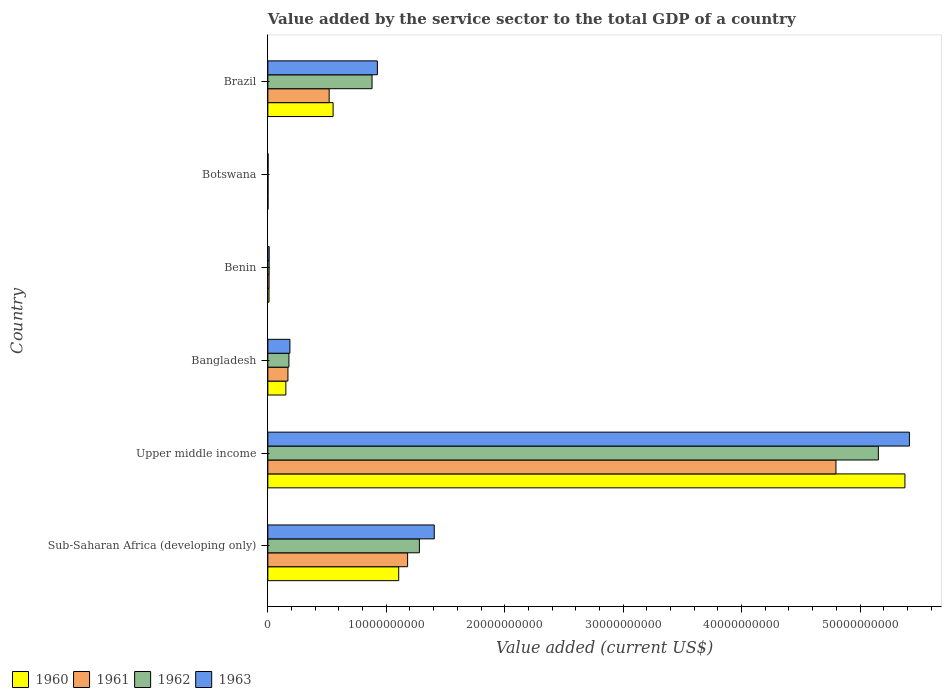How many different coloured bars are there?
Ensure brevity in your answer.  4. How many groups of bars are there?
Your answer should be very brief. 6. How many bars are there on the 1st tick from the bottom?
Provide a short and direct response. 4. What is the label of the 2nd group of bars from the top?
Ensure brevity in your answer.  Botswana. In how many cases, is the number of bars for a given country not equal to the number of legend labels?
Your response must be concise. 0. What is the value added by the service sector to the total GDP in 1963 in Brazil?
Provide a succinct answer. 9.25e+09. Across all countries, what is the maximum value added by the service sector to the total GDP in 1961?
Give a very brief answer. 4.80e+1. Across all countries, what is the minimum value added by the service sector to the total GDP in 1961?
Offer a terse response. 1.51e+07. In which country was the value added by the service sector to the total GDP in 1963 maximum?
Keep it short and to the point. Upper middle income. In which country was the value added by the service sector to the total GDP in 1962 minimum?
Offer a very short reply. Botswana. What is the total value added by the service sector to the total GDP in 1963 in the graph?
Keep it short and to the point. 7.95e+1. What is the difference between the value added by the service sector to the total GDP in 1961 in Bangladesh and that in Benin?
Provide a succinct answer. 1.59e+09. What is the difference between the value added by the service sector to the total GDP in 1960 in Sub-Saharan Africa (developing only) and the value added by the service sector to the total GDP in 1961 in Brazil?
Offer a very short reply. 5.87e+09. What is the average value added by the service sector to the total GDP in 1960 per country?
Ensure brevity in your answer.  1.20e+1. What is the difference between the value added by the service sector to the total GDP in 1961 and value added by the service sector to the total GDP in 1960 in Sub-Saharan Africa (developing only)?
Give a very brief answer. 7.52e+08. What is the ratio of the value added by the service sector to the total GDP in 1960 in Benin to that in Botswana?
Provide a short and direct response. 7.52. Is the value added by the service sector to the total GDP in 1961 in Bangladesh less than that in Sub-Saharan Africa (developing only)?
Make the answer very short. Yes. Is the difference between the value added by the service sector to the total GDP in 1961 in Benin and Botswana greater than the difference between the value added by the service sector to the total GDP in 1960 in Benin and Botswana?
Provide a succinct answer. Yes. What is the difference between the highest and the second highest value added by the service sector to the total GDP in 1961?
Keep it short and to the point. 3.62e+1. What is the difference between the highest and the lowest value added by the service sector to the total GDP in 1962?
Your answer should be compact. 5.15e+1. In how many countries, is the value added by the service sector to the total GDP in 1961 greater than the average value added by the service sector to the total GDP in 1961 taken over all countries?
Your answer should be very brief. 2. What does the 2nd bar from the top in Botswana represents?
Your answer should be very brief. 1962. What does the 2nd bar from the bottom in Bangladesh represents?
Keep it short and to the point. 1961. Are all the bars in the graph horizontal?
Your response must be concise. Yes. What is the difference between two consecutive major ticks on the X-axis?
Offer a terse response. 1.00e+1. Does the graph contain grids?
Keep it short and to the point. No. Where does the legend appear in the graph?
Make the answer very short. Bottom left. What is the title of the graph?
Offer a very short reply. Value added by the service sector to the total GDP of a country. Does "1988" appear as one of the legend labels in the graph?
Give a very brief answer. No. What is the label or title of the X-axis?
Your answer should be very brief. Value added (current US$). What is the label or title of the Y-axis?
Your response must be concise. Country. What is the Value added (current US$) of 1960 in Sub-Saharan Africa (developing only)?
Ensure brevity in your answer.  1.10e+1. What is the Value added (current US$) of 1961 in Sub-Saharan Africa (developing only)?
Your answer should be compact. 1.18e+1. What is the Value added (current US$) of 1962 in Sub-Saharan Africa (developing only)?
Give a very brief answer. 1.28e+1. What is the Value added (current US$) of 1963 in Sub-Saharan Africa (developing only)?
Your response must be concise. 1.41e+1. What is the Value added (current US$) of 1960 in Upper middle income?
Offer a terse response. 5.38e+1. What is the Value added (current US$) in 1961 in Upper middle income?
Offer a very short reply. 4.80e+1. What is the Value added (current US$) in 1962 in Upper middle income?
Give a very brief answer. 5.16e+1. What is the Value added (current US$) in 1963 in Upper middle income?
Ensure brevity in your answer.  5.42e+1. What is the Value added (current US$) of 1960 in Bangladesh?
Keep it short and to the point. 1.52e+09. What is the Value added (current US$) in 1961 in Bangladesh?
Your response must be concise. 1.70e+09. What is the Value added (current US$) in 1962 in Bangladesh?
Give a very brief answer. 1.78e+09. What is the Value added (current US$) in 1963 in Bangladesh?
Keep it short and to the point. 1.86e+09. What is the Value added (current US$) of 1960 in Benin?
Keep it short and to the point. 9.87e+07. What is the Value added (current US$) of 1961 in Benin?
Provide a short and direct response. 1.04e+08. What is the Value added (current US$) in 1962 in Benin?
Ensure brevity in your answer.  1.08e+08. What is the Value added (current US$) of 1963 in Benin?
Your response must be concise. 1.14e+08. What is the Value added (current US$) of 1960 in Botswana?
Offer a terse response. 1.31e+07. What is the Value added (current US$) of 1961 in Botswana?
Your response must be concise. 1.51e+07. What is the Value added (current US$) in 1962 in Botswana?
Ensure brevity in your answer.  1.73e+07. What is the Value added (current US$) of 1963 in Botswana?
Offer a very short reply. 1.93e+07. What is the Value added (current US$) of 1960 in Brazil?
Make the answer very short. 5.51e+09. What is the Value added (current US$) of 1961 in Brazil?
Provide a short and direct response. 5.18e+09. What is the Value added (current US$) in 1962 in Brazil?
Give a very brief answer. 8.80e+09. What is the Value added (current US$) in 1963 in Brazil?
Offer a terse response. 9.25e+09. Across all countries, what is the maximum Value added (current US$) in 1960?
Provide a succinct answer. 5.38e+1. Across all countries, what is the maximum Value added (current US$) in 1961?
Your response must be concise. 4.80e+1. Across all countries, what is the maximum Value added (current US$) of 1962?
Provide a succinct answer. 5.16e+1. Across all countries, what is the maximum Value added (current US$) of 1963?
Provide a short and direct response. 5.42e+1. Across all countries, what is the minimum Value added (current US$) of 1960?
Ensure brevity in your answer.  1.31e+07. Across all countries, what is the minimum Value added (current US$) in 1961?
Make the answer very short. 1.51e+07. Across all countries, what is the minimum Value added (current US$) of 1962?
Your answer should be compact. 1.73e+07. Across all countries, what is the minimum Value added (current US$) in 1963?
Provide a succinct answer. 1.93e+07. What is the total Value added (current US$) in 1960 in the graph?
Provide a short and direct response. 7.20e+1. What is the total Value added (current US$) in 1961 in the graph?
Offer a terse response. 6.68e+1. What is the total Value added (current US$) in 1962 in the graph?
Your answer should be compact. 7.50e+1. What is the total Value added (current US$) in 1963 in the graph?
Your answer should be very brief. 7.95e+1. What is the difference between the Value added (current US$) in 1960 in Sub-Saharan Africa (developing only) and that in Upper middle income?
Make the answer very short. -4.27e+1. What is the difference between the Value added (current US$) of 1961 in Sub-Saharan Africa (developing only) and that in Upper middle income?
Ensure brevity in your answer.  -3.62e+1. What is the difference between the Value added (current US$) of 1962 in Sub-Saharan Africa (developing only) and that in Upper middle income?
Make the answer very short. -3.88e+1. What is the difference between the Value added (current US$) of 1963 in Sub-Saharan Africa (developing only) and that in Upper middle income?
Ensure brevity in your answer.  -4.01e+1. What is the difference between the Value added (current US$) of 1960 in Sub-Saharan Africa (developing only) and that in Bangladesh?
Offer a terse response. 9.53e+09. What is the difference between the Value added (current US$) of 1961 in Sub-Saharan Africa (developing only) and that in Bangladesh?
Provide a succinct answer. 1.01e+1. What is the difference between the Value added (current US$) in 1962 in Sub-Saharan Africa (developing only) and that in Bangladesh?
Give a very brief answer. 1.10e+1. What is the difference between the Value added (current US$) of 1963 in Sub-Saharan Africa (developing only) and that in Bangladesh?
Provide a short and direct response. 1.22e+1. What is the difference between the Value added (current US$) of 1960 in Sub-Saharan Africa (developing only) and that in Benin?
Make the answer very short. 1.10e+1. What is the difference between the Value added (current US$) of 1961 in Sub-Saharan Africa (developing only) and that in Benin?
Your response must be concise. 1.17e+1. What is the difference between the Value added (current US$) of 1962 in Sub-Saharan Africa (developing only) and that in Benin?
Give a very brief answer. 1.27e+1. What is the difference between the Value added (current US$) in 1963 in Sub-Saharan Africa (developing only) and that in Benin?
Make the answer very short. 1.39e+1. What is the difference between the Value added (current US$) of 1960 in Sub-Saharan Africa (developing only) and that in Botswana?
Provide a short and direct response. 1.10e+1. What is the difference between the Value added (current US$) in 1961 in Sub-Saharan Africa (developing only) and that in Botswana?
Offer a very short reply. 1.18e+1. What is the difference between the Value added (current US$) in 1962 in Sub-Saharan Africa (developing only) and that in Botswana?
Keep it short and to the point. 1.28e+1. What is the difference between the Value added (current US$) in 1963 in Sub-Saharan Africa (developing only) and that in Botswana?
Your answer should be very brief. 1.40e+1. What is the difference between the Value added (current US$) in 1960 in Sub-Saharan Africa (developing only) and that in Brazil?
Give a very brief answer. 5.54e+09. What is the difference between the Value added (current US$) in 1961 in Sub-Saharan Africa (developing only) and that in Brazil?
Make the answer very short. 6.62e+09. What is the difference between the Value added (current US$) of 1962 in Sub-Saharan Africa (developing only) and that in Brazil?
Ensure brevity in your answer.  4.00e+09. What is the difference between the Value added (current US$) in 1963 in Sub-Saharan Africa (developing only) and that in Brazil?
Keep it short and to the point. 4.80e+09. What is the difference between the Value added (current US$) in 1960 in Upper middle income and that in Bangladesh?
Your response must be concise. 5.23e+1. What is the difference between the Value added (current US$) of 1961 in Upper middle income and that in Bangladesh?
Provide a succinct answer. 4.63e+1. What is the difference between the Value added (current US$) of 1962 in Upper middle income and that in Bangladesh?
Your answer should be very brief. 4.98e+1. What is the difference between the Value added (current US$) in 1963 in Upper middle income and that in Bangladesh?
Offer a terse response. 5.23e+1. What is the difference between the Value added (current US$) in 1960 in Upper middle income and that in Benin?
Your answer should be compact. 5.37e+1. What is the difference between the Value added (current US$) of 1961 in Upper middle income and that in Benin?
Offer a terse response. 4.79e+1. What is the difference between the Value added (current US$) of 1962 in Upper middle income and that in Benin?
Ensure brevity in your answer.  5.14e+1. What is the difference between the Value added (current US$) in 1963 in Upper middle income and that in Benin?
Your answer should be compact. 5.41e+1. What is the difference between the Value added (current US$) of 1960 in Upper middle income and that in Botswana?
Make the answer very short. 5.38e+1. What is the difference between the Value added (current US$) of 1961 in Upper middle income and that in Botswana?
Make the answer very short. 4.80e+1. What is the difference between the Value added (current US$) in 1962 in Upper middle income and that in Botswana?
Keep it short and to the point. 5.15e+1. What is the difference between the Value added (current US$) of 1963 in Upper middle income and that in Botswana?
Offer a terse response. 5.42e+1. What is the difference between the Value added (current US$) in 1960 in Upper middle income and that in Brazil?
Offer a terse response. 4.83e+1. What is the difference between the Value added (current US$) in 1961 in Upper middle income and that in Brazil?
Keep it short and to the point. 4.28e+1. What is the difference between the Value added (current US$) in 1962 in Upper middle income and that in Brazil?
Give a very brief answer. 4.28e+1. What is the difference between the Value added (current US$) in 1963 in Upper middle income and that in Brazil?
Provide a short and direct response. 4.49e+1. What is the difference between the Value added (current US$) of 1960 in Bangladesh and that in Benin?
Provide a succinct answer. 1.42e+09. What is the difference between the Value added (current US$) of 1961 in Bangladesh and that in Benin?
Make the answer very short. 1.59e+09. What is the difference between the Value added (current US$) of 1962 in Bangladesh and that in Benin?
Give a very brief answer. 1.67e+09. What is the difference between the Value added (current US$) of 1963 in Bangladesh and that in Benin?
Keep it short and to the point. 1.75e+09. What is the difference between the Value added (current US$) in 1960 in Bangladesh and that in Botswana?
Offer a terse response. 1.51e+09. What is the difference between the Value added (current US$) of 1961 in Bangladesh and that in Botswana?
Your answer should be compact. 1.68e+09. What is the difference between the Value added (current US$) of 1962 in Bangladesh and that in Botswana?
Keep it short and to the point. 1.76e+09. What is the difference between the Value added (current US$) of 1963 in Bangladesh and that in Botswana?
Offer a terse response. 1.85e+09. What is the difference between the Value added (current US$) in 1960 in Bangladesh and that in Brazil?
Your answer should be compact. -3.99e+09. What is the difference between the Value added (current US$) of 1961 in Bangladesh and that in Brazil?
Ensure brevity in your answer.  -3.48e+09. What is the difference between the Value added (current US$) in 1962 in Bangladesh and that in Brazil?
Provide a succinct answer. -7.02e+09. What is the difference between the Value added (current US$) in 1963 in Bangladesh and that in Brazil?
Keep it short and to the point. -7.38e+09. What is the difference between the Value added (current US$) in 1960 in Benin and that in Botswana?
Your answer should be compact. 8.55e+07. What is the difference between the Value added (current US$) of 1961 in Benin and that in Botswana?
Offer a very short reply. 8.86e+07. What is the difference between the Value added (current US$) of 1962 in Benin and that in Botswana?
Offer a very short reply. 9.03e+07. What is the difference between the Value added (current US$) of 1963 in Benin and that in Botswana?
Provide a short and direct response. 9.45e+07. What is the difference between the Value added (current US$) in 1960 in Benin and that in Brazil?
Offer a very short reply. -5.41e+09. What is the difference between the Value added (current US$) of 1961 in Benin and that in Brazil?
Give a very brief answer. -5.07e+09. What is the difference between the Value added (current US$) of 1962 in Benin and that in Brazil?
Ensure brevity in your answer.  -8.69e+09. What is the difference between the Value added (current US$) of 1963 in Benin and that in Brazil?
Provide a succinct answer. -9.13e+09. What is the difference between the Value added (current US$) of 1960 in Botswana and that in Brazil?
Give a very brief answer. -5.50e+09. What is the difference between the Value added (current US$) of 1961 in Botswana and that in Brazil?
Your response must be concise. -5.16e+09. What is the difference between the Value added (current US$) in 1962 in Botswana and that in Brazil?
Offer a very short reply. -8.78e+09. What is the difference between the Value added (current US$) of 1963 in Botswana and that in Brazil?
Give a very brief answer. -9.23e+09. What is the difference between the Value added (current US$) in 1960 in Sub-Saharan Africa (developing only) and the Value added (current US$) in 1961 in Upper middle income?
Offer a terse response. -3.69e+1. What is the difference between the Value added (current US$) of 1960 in Sub-Saharan Africa (developing only) and the Value added (current US$) of 1962 in Upper middle income?
Your answer should be very brief. -4.05e+1. What is the difference between the Value added (current US$) of 1960 in Sub-Saharan Africa (developing only) and the Value added (current US$) of 1963 in Upper middle income?
Your answer should be compact. -4.31e+1. What is the difference between the Value added (current US$) of 1961 in Sub-Saharan Africa (developing only) and the Value added (current US$) of 1962 in Upper middle income?
Provide a short and direct response. -3.97e+1. What is the difference between the Value added (current US$) in 1961 in Sub-Saharan Africa (developing only) and the Value added (current US$) in 1963 in Upper middle income?
Your answer should be compact. -4.24e+1. What is the difference between the Value added (current US$) in 1962 in Sub-Saharan Africa (developing only) and the Value added (current US$) in 1963 in Upper middle income?
Offer a very short reply. -4.14e+1. What is the difference between the Value added (current US$) of 1960 in Sub-Saharan Africa (developing only) and the Value added (current US$) of 1961 in Bangladesh?
Provide a succinct answer. 9.35e+09. What is the difference between the Value added (current US$) of 1960 in Sub-Saharan Africa (developing only) and the Value added (current US$) of 1962 in Bangladesh?
Offer a very short reply. 9.27e+09. What is the difference between the Value added (current US$) in 1960 in Sub-Saharan Africa (developing only) and the Value added (current US$) in 1963 in Bangladesh?
Keep it short and to the point. 9.19e+09. What is the difference between the Value added (current US$) of 1961 in Sub-Saharan Africa (developing only) and the Value added (current US$) of 1962 in Bangladesh?
Provide a succinct answer. 1.00e+1. What is the difference between the Value added (current US$) of 1961 in Sub-Saharan Africa (developing only) and the Value added (current US$) of 1963 in Bangladesh?
Make the answer very short. 9.94e+09. What is the difference between the Value added (current US$) in 1962 in Sub-Saharan Africa (developing only) and the Value added (current US$) in 1963 in Bangladesh?
Keep it short and to the point. 1.09e+1. What is the difference between the Value added (current US$) of 1960 in Sub-Saharan Africa (developing only) and the Value added (current US$) of 1961 in Benin?
Your response must be concise. 1.09e+1. What is the difference between the Value added (current US$) of 1960 in Sub-Saharan Africa (developing only) and the Value added (current US$) of 1962 in Benin?
Offer a very short reply. 1.09e+1. What is the difference between the Value added (current US$) of 1960 in Sub-Saharan Africa (developing only) and the Value added (current US$) of 1963 in Benin?
Keep it short and to the point. 1.09e+1. What is the difference between the Value added (current US$) in 1961 in Sub-Saharan Africa (developing only) and the Value added (current US$) in 1962 in Benin?
Provide a succinct answer. 1.17e+1. What is the difference between the Value added (current US$) in 1961 in Sub-Saharan Africa (developing only) and the Value added (current US$) in 1963 in Benin?
Ensure brevity in your answer.  1.17e+1. What is the difference between the Value added (current US$) in 1962 in Sub-Saharan Africa (developing only) and the Value added (current US$) in 1963 in Benin?
Keep it short and to the point. 1.27e+1. What is the difference between the Value added (current US$) in 1960 in Sub-Saharan Africa (developing only) and the Value added (current US$) in 1961 in Botswana?
Offer a terse response. 1.10e+1. What is the difference between the Value added (current US$) in 1960 in Sub-Saharan Africa (developing only) and the Value added (current US$) in 1962 in Botswana?
Make the answer very short. 1.10e+1. What is the difference between the Value added (current US$) of 1960 in Sub-Saharan Africa (developing only) and the Value added (current US$) of 1963 in Botswana?
Give a very brief answer. 1.10e+1. What is the difference between the Value added (current US$) in 1961 in Sub-Saharan Africa (developing only) and the Value added (current US$) in 1962 in Botswana?
Provide a succinct answer. 1.18e+1. What is the difference between the Value added (current US$) of 1961 in Sub-Saharan Africa (developing only) and the Value added (current US$) of 1963 in Botswana?
Give a very brief answer. 1.18e+1. What is the difference between the Value added (current US$) of 1962 in Sub-Saharan Africa (developing only) and the Value added (current US$) of 1963 in Botswana?
Make the answer very short. 1.28e+1. What is the difference between the Value added (current US$) of 1960 in Sub-Saharan Africa (developing only) and the Value added (current US$) of 1961 in Brazil?
Your response must be concise. 5.87e+09. What is the difference between the Value added (current US$) in 1960 in Sub-Saharan Africa (developing only) and the Value added (current US$) in 1962 in Brazil?
Your response must be concise. 2.25e+09. What is the difference between the Value added (current US$) of 1960 in Sub-Saharan Africa (developing only) and the Value added (current US$) of 1963 in Brazil?
Ensure brevity in your answer.  1.80e+09. What is the difference between the Value added (current US$) of 1961 in Sub-Saharan Africa (developing only) and the Value added (current US$) of 1962 in Brazil?
Offer a very short reply. 3.00e+09. What is the difference between the Value added (current US$) of 1961 in Sub-Saharan Africa (developing only) and the Value added (current US$) of 1963 in Brazil?
Your answer should be very brief. 2.55e+09. What is the difference between the Value added (current US$) of 1962 in Sub-Saharan Africa (developing only) and the Value added (current US$) of 1963 in Brazil?
Your answer should be very brief. 3.55e+09. What is the difference between the Value added (current US$) of 1960 in Upper middle income and the Value added (current US$) of 1961 in Bangladesh?
Make the answer very short. 5.21e+1. What is the difference between the Value added (current US$) in 1960 in Upper middle income and the Value added (current US$) in 1962 in Bangladesh?
Provide a succinct answer. 5.20e+1. What is the difference between the Value added (current US$) in 1960 in Upper middle income and the Value added (current US$) in 1963 in Bangladesh?
Your answer should be very brief. 5.19e+1. What is the difference between the Value added (current US$) of 1961 in Upper middle income and the Value added (current US$) of 1962 in Bangladesh?
Keep it short and to the point. 4.62e+1. What is the difference between the Value added (current US$) in 1961 in Upper middle income and the Value added (current US$) in 1963 in Bangladesh?
Give a very brief answer. 4.61e+1. What is the difference between the Value added (current US$) of 1962 in Upper middle income and the Value added (current US$) of 1963 in Bangladesh?
Your answer should be compact. 4.97e+1. What is the difference between the Value added (current US$) of 1960 in Upper middle income and the Value added (current US$) of 1961 in Benin?
Make the answer very short. 5.37e+1. What is the difference between the Value added (current US$) in 1960 in Upper middle income and the Value added (current US$) in 1962 in Benin?
Provide a succinct answer. 5.37e+1. What is the difference between the Value added (current US$) in 1960 in Upper middle income and the Value added (current US$) in 1963 in Benin?
Offer a terse response. 5.37e+1. What is the difference between the Value added (current US$) in 1961 in Upper middle income and the Value added (current US$) in 1962 in Benin?
Keep it short and to the point. 4.79e+1. What is the difference between the Value added (current US$) in 1961 in Upper middle income and the Value added (current US$) in 1963 in Benin?
Your answer should be very brief. 4.79e+1. What is the difference between the Value added (current US$) of 1962 in Upper middle income and the Value added (current US$) of 1963 in Benin?
Give a very brief answer. 5.14e+1. What is the difference between the Value added (current US$) of 1960 in Upper middle income and the Value added (current US$) of 1961 in Botswana?
Make the answer very short. 5.38e+1. What is the difference between the Value added (current US$) of 1960 in Upper middle income and the Value added (current US$) of 1962 in Botswana?
Offer a terse response. 5.38e+1. What is the difference between the Value added (current US$) in 1960 in Upper middle income and the Value added (current US$) in 1963 in Botswana?
Offer a terse response. 5.38e+1. What is the difference between the Value added (current US$) of 1961 in Upper middle income and the Value added (current US$) of 1962 in Botswana?
Keep it short and to the point. 4.80e+1. What is the difference between the Value added (current US$) in 1961 in Upper middle income and the Value added (current US$) in 1963 in Botswana?
Offer a terse response. 4.80e+1. What is the difference between the Value added (current US$) of 1962 in Upper middle income and the Value added (current US$) of 1963 in Botswana?
Provide a succinct answer. 5.15e+1. What is the difference between the Value added (current US$) of 1960 in Upper middle income and the Value added (current US$) of 1961 in Brazil?
Ensure brevity in your answer.  4.86e+1. What is the difference between the Value added (current US$) in 1960 in Upper middle income and the Value added (current US$) in 1962 in Brazil?
Your response must be concise. 4.50e+1. What is the difference between the Value added (current US$) in 1960 in Upper middle income and the Value added (current US$) in 1963 in Brazil?
Provide a short and direct response. 4.45e+1. What is the difference between the Value added (current US$) in 1961 in Upper middle income and the Value added (current US$) in 1962 in Brazil?
Your answer should be compact. 3.92e+1. What is the difference between the Value added (current US$) of 1961 in Upper middle income and the Value added (current US$) of 1963 in Brazil?
Keep it short and to the point. 3.87e+1. What is the difference between the Value added (current US$) in 1962 in Upper middle income and the Value added (current US$) in 1963 in Brazil?
Offer a terse response. 4.23e+1. What is the difference between the Value added (current US$) of 1960 in Bangladesh and the Value added (current US$) of 1961 in Benin?
Provide a succinct answer. 1.42e+09. What is the difference between the Value added (current US$) in 1960 in Bangladesh and the Value added (current US$) in 1962 in Benin?
Offer a very short reply. 1.41e+09. What is the difference between the Value added (current US$) of 1960 in Bangladesh and the Value added (current US$) of 1963 in Benin?
Offer a very short reply. 1.41e+09. What is the difference between the Value added (current US$) in 1961 in Bangladesh and the Value added (current US$) in 1962 in Benin?
Offer a very short reply. 1.59e+09. What is the difference between the Value added (current US$) of 1961 in Bangladesh and the Value added (current US$) of 1963 in Benin?
Make the answer very short. 1.58e+09. What is the difference between the Value added (current US$) in 1962 in Bangladesh and the Value added (current US$) in 1963 in Benin?
Give a very brief answer. 1.67e+09. What is the difference between the Value added (current US$) in 1960 in Bangladesh and the Value added (current US$) in 1961 in Botswana?
Give a very brief answer. 1.50e+09. What is the difference between the Value added (current US$) in 1960 in Bangladesh and the Value added (current US$) in 1962 in Botswana?
Provide a succinct answer. 1.50e+09. What is the difference between the Value added (current US$) in 1960 in Bangladesh and the Value added (current US$) in 1963 in Botswana?
Keep it short and to the point. 1.50e+09. What is the difference between the Value added (current US$) in 1961 in Bangladesh and the Value added (current US$) in 1962 in Botswana?
Your answer should be compact. 1.68e+09. What is the difference between the Value added (current US$) of 1961 in Bangladesh and the Value added (current US$) of 1963 in Botswana?
Your answer should be very brief. 1.68e+09. What is the difference between the Value added (current US$) in 1962 in Bangladesh and the Value added (current US$) in 1963 in Botswana?
Your response must be concise. 1.76e+09. What is the difference between the Value added (current US$) of 1960 in Bangladesh and the Value added (current US$) of 1961 in Brazil?
Your answer should be very brief. -3.66e+09. What is the difference between the Value added (current US$) in 1960 in Bangladesh and the Value added (current US$) in 1962 in Brazil?
Keep it short and to the point. -7.28e+09. What is the difference between the Value added (current US$) of 1960 in Bangladesh and the Value added (current US$) of 1963 in Brazil?
Make the answer very short. -7.73e+09. What is the difference between the Value added (current US$) in 1961 in Bangladesh and the Value added (current US$) in 1962 in Brazil?
Provide a short and direct response. -7.10e+09. What is the difference between the Value added (current US$) in 1961 in Bangladesh and the Value added (current US$) in 1963 in Brazil?
Offer a very short reply. -7.55e+09. What is the difference between the Value added (current US$) of 1962 in Bangladesh and the Value added (current US$) of 1963 in Brazil?
Provide a short and direct response. -7.47e+09. What is the difference between the Value added (current US$) of 1960 in Benin and the Value added (current US$) of 1961 in Botswana?
Ensure brevity in your answer.  8.36e+07. What is the difference between the Value added (current US$) in 1960 in Benin and the Value added (current US$) in 1962 in Botswana?
Give a very brief answer. 8.14e+07. What is the difference between the Value added (current US$) in 1960 in Benin and the Value added (current US$) in 1963 in Botswana?
Make the answer very short. 7.94e+07. What is the difference between the Value added (current US$) of 1961 in Benin and the Value added (current US$) of 1962 in Botswana?
Keep it short and to the point. 8.64e+07. What is the difference between the Value added (current US$) in 1961 in Benin and the Value added (current US$) in 1963 in Botswana?
Make the answer very short. 8.44e+07. What is the difference between the Value added (current US$) of 1962 in Benin and the Value added (current US$) of 1963 in Botswana?
Ensure brevity in your answer.  8.83e+07. What is the difference between the Value added (current US$) of 1960 in Benin and the Value added (current US$) of 1961 in Brazil?
Your answer should be compact. -5.08e+09. What is the difference between the Value added (current US$) of 1960 in Benin and the Value added (current US$) of 1962 in Brazil?
Your response must be concise. -8.70e+09. What is the difference between the Value added (current US$) in 1960 in Benin and the Value added (current US$) in 1963 in Brazil?
Offer a terse response. -9.15e+09. What is the difference between the Value added (current US$) of 1961 in Benin and the Value added (current US$) of 1962 in Brazil?
Your answer should be compact. -8.70e+09. What is the difference between the Value added (current US$) in 1961 in Benin and the Value added (current US$) in 1963 in Brazil?
Your response must be concise. -9.14e+09. What is the difference between the Value added (current US$) of 1962 in Benin and the Value added (current US$) of 1963 in Brazil?
Your answer should be very brief. -9.14e+09. What is the difference between the Value added (current US$) of 1960 in Botswana and the Value added (current US$) of 1961 in Brazil?
Your answer should be very brief. -5.17e+09. What is the difference between the Value added (current US$) in 1960 in Botswana and the Value added (current US$) in 1962 in Brazil?
Provide a succinct answer. -8.79e+09. What is the difference between the Value added (current US$) of 1960 in Botswana and the Value added (current US$) of 1963 in Brazil?
Your answer should be very brief. -9.24e+09. What is the difference between the Value added (current US$) of 1961 in Botswana and the Value added (current US$) of 1962 in Brazil?
Your answer should be compact. -8.78e+09. What is the difference between the Value added (current US$) in 1961 in Botswana and the Value added (current US$) in 1963 in Brazil?
Ensure brevity in your answer.  -9.23e+09. What is the difference between the Value added (current US$) in 1962 in Botswana and the Value added (current US$) in 1963 in Brazil?
Give a very brief answer. -9.23e+09. What is the average Value added (current US$) in 1960 per country?
Make the answer very short. 1.20e+1. What is the average Value added (current US$) in 1961 per country?
Provide a succinct answer. 1.11e+1. What is the average Value added (current US$) of 1962 per country?
Provide a succinct answer. 1.25e+1. What is the average Value added (current US$) of 1963 per country?
Your response must be concise. 1.32e+1. What is the difference between the Value added (current US$) in 1960 and Value added (current US$) in 1961 in Sub-Saharan Africa (developing only)?
Your response must be concise. -7.52e+08. What is the difference between the Value added (current US$) in 1960 and Value added (current US$) in 1962 in Sub-Saharan Africa (developing only)?
Offer a terse response. -1.75e+09. What is the difference between the Value added (current US$) in 1960 and Value added (current US$) in 1963 in Sub-Saharan Africa (developing only)?
Keep it short and to the point. -3.00e+09. What is the difference between the Value added (current US$) in 1961 and Value added (current US$) in 1962 in Sub-Saharan Africa (developing only)?
Keep it short and to the point. -9.93e+08. What is the difference between the Value added (current US$) of 1961 and Value added (current US$) of 1963 in Sub-Saharan Africa (developing only)?
Your answer should be very brief. -2.25e+09. What is the difference between the Value added (current US$) of 1962 and Value added (current US$) of 1963 in Sub-Saharan Africa (developing only)?
Offer a terse response. -1.26e+09. What is the difference between the Value added (current US$) of 1960 and Value added (current US$) of 1961 in Upper middle income?
Provide a short and direct response. 5.82e+09. What is the difference between the Value added (current US$) of 1960 and Value added (current US$) of 1962 in Upper middle income?
Give a very brief answer. 2.24e+09. What is the difference between the Value added (current US$) of 1960 and Value added (current US$) of 1963 in Upper middle income?
Give a very brief answer. -3.78e+08. What is the difference between the Value added (current US$) in 1961 and Value added (current US$) in 1962 in Upper middle income?
Make the answer very short. -3.58e+09. What is the difference between the Value added (current US$) of 1961 and Value added (current US$) of 1963 in Upper middle income?
Give a very brief answer. -6.20e+09. What is the difference between the Value added (current US$) in 1962 and Value added (current US$) in 1963 in Upper middle income?
Your answer should be compact. -2.62e+09. What is the difference between the Value added (current US$) of 1960 and Value added (current US$) of 1961 in Bangladesh?
Ensure brevity in your answer.  -1.77e+08. What is the difference between the Value added (current US$) in 1960 and Value added (current US$) in 1962 in Bangladesh?
Give a very brief answer. -2.60e+08. What is the difference between the Value added (current US$) of 1960 and Value added (current US$) of 1963 in Bangladesh?
Offer a terse response. -3.45e+08. What is the difference between the Value added (current US$) in 1961 and Value added (current US$) in 1962 in Bangladesh?
Your answer should be very brief. -8.27e+07. What is the difference between the Value added (current US$) of 1961 and Value added (current US$) of 1963 in Bangladesh?
Give a very brief answer. -1.68e+08. What is the difference between the Value added (current US$) in 1962 and Value added (current US$) in 1963 in Bangladesh?
Provide a short and direct response. -8.50e+07. What is the difference between the Value added (current US$) of 1960 and Value added (current US$) of 1961 in Benin?
Keep it short and to the point. -5.02e+06. What is the difference between the Value added (current US$) in 1960 and Value added (current US$) in 1962 in Benin?
Your answer should be compact. -8.92e+06. What is the difference between the Value added (current US$) of 1960 and Value added (current US$) of 1963 in Benin?
Provide a short and direct response. -1.51e+07. What is the difference between the Value added (current US$) in 1961 and Value added (current US$) in 1962 in Benin?
Give a very brief answer. -3.90e+06. What is the difference between the Value added (current US$) of 1961 and Value added (current US$) of 1963 in Benin?
Keep it short and to the point. -1.01e+07. What is the difference between the Value added (current US$) in 1962 and Value added (current US$) in 1963 in Benin?
Offer a very short reply. -6.21e+06. What is the difference between the Value added (current US$) in 1960 and Value added (current US$) in 1961 in Botswana?
Offer a very short reply. -1.99e+06. What is the difference between the Value added (current US$) in 1960 and Value added (current US$) in 1962 in Botswana?
Give a very brief answer. -4.17e+06. What is the difference between the Value added (current US$) of 1960 and Value added (current US$) of 1963 in Botswana?
Your answer should be compact. -6.14e+06. What is the difference between the Value added (current US$) in 1961 and Value added (current US$) in 1962 in Botswana?
Provide a short and direct response. -2.18e+06. What is the difference between the Value added (current US$) of 1961 and Value added (current US$) of 1963 in Botswana?
Give a very brief answer. -4.15e+06. What is the difference between the Value added (current US$) in 1962 and Value added (current US$) in 1963 in Botswana?
Keep it short and to the point. -1.97e+06. What is the difference between the Value added (current US$) in 1960 and Value added (current US$) in 1961 in Brazil?
Provide a succinct answer. 3.31e+08. What is the difference between the Value added (current US$) in 1960 and Value added (current US$) in 1962 in Brazil?
Your answer should be very brief. -3.29e+09. What is the difference between the Value added (current US$) in 1960 and Value added (current US$) in 1963 in Brazil?
Make the answer very short. -3.74e+09. What is the difference between the Value added (current US$) of 1961 and Value added (current US$) of 1962 in Brazil?
Keep it short and to the point. -3.62e+09. What is the difference between the Value added (current US$) of 1961 and Value added (current US$) of 1963 in Brazil?
Your answer should be compact. -4.07e+09. What is the difference between the Value added (current US$) of 1962 and Value added (current US$) of 1963 in Brazil?
Give a very brief answer. -4.49e+08. What is the ratio of the Value added (current US$) in 1960 in Sub-Saharan Africa (developing only) to that in Upper middle income?
Provide a short and direct response. 0.21. What is the ratio of the Value added (current US$) in 1961 in Sub-Saharan Africa (developing only) to that in Upper middle income?
Ensure brevity in your answer.  0.25. What is the ratio of the Value added (current US$) in 1962 in Sub-Saharan Africa (developing only) to that in Upper middle income?
Provide a short and direct response. 0.25. What is the ratio of the Value added (current US$) of 1963 in Sub-Saharan Africa (developing only) to that in Upper middle income?
Provide a short and direct response. 0.26. What is the ratio of the Value added (current US$) in 1960 in Sub-Saharan Africa (developing only) to that in Bangladesh?
Offer a terse response. 7.27. What is the ratio of the Value added (current US$) of 1961 in Sub-Saharan Africa (developing only) to that in Bangladesh?
Offer a terse response. 6.96. What is the ratio of the Value added (current US$) in 1962 in Sub-Saharan Africa (developing only) to that in Bangladesh?
Offer a very short reply. 7.19. What is the ratio of the Value added (current US$) of 1963 in Sub-Saharan Africa (developing only) to that in Bangladesh?
Your response must be concise. 7.54. What is the ratio of the Value added (current US$) in 1960 in Sub-Saharan Africa (developing only) to that in Benin?
Give a very brief answer. 112. What is the ratio of the Value added (current US$) in 1961 in Sub-Saharan Africa (developing only) to that in Benin?
Offer a very short reply. 113.83. What is the ratio of the Value added (current US$) in 1962 in Sub-Saharan Africa (developing only) to that in Benin?
Offer a very short reply. 118.94. What is the ratio of the Value added (current US$) of 1963 in Sub-Saharan Africa (developing only) to that in Benin?
Your response must be concise. 123.48. What is the ratio of the Value added (current US$) of 1960 in Sub-Saharan Africa (developing only) to that in Botswana?
Give a very brief answer. 842.63. What is the ratio of the Value added (current US$) of 1961 in Sub-Saharan Africa (developing only) to that in Botswana?
Provide a short and direct response. 781.31. What is the ratio of the Value added (current US$) in 1962 in Sub-Saharan Africa (developing only) to that in Botswana?
Keep it short and to the point. 740.25. What is the ratio of the Value added (current US$) of 1963 in Sub-Saharan Africa (developing only) to that in Botswana?
Your answer should be compact. 729.9. What is the ratio of the Value added (current US$) of 1960 in Sub-Saharan Africa (developing only) to that in Brazil?
Provide a succinct answer. 2.01. What is the ratio of the Value added (current US$) of 1961 in Sub-Saharan Africa (developing only) to that in Brazil?
Offer a very short reply. 2.28. What is the ratio of the Value added (current US$) in 1962 in Sub-Saharan Africa (developing only) to that in Brazil?
Offer a terse response. 1.45. What is the ratio of the Value added (current US$) in 1963 in Sub-Saharan Africa (developing only) to that in Brazil?
Offer a very short reply. 1.52. What is the ratio of the Value added (current US$) of 1960 in Upper middle income to that in Bangladesh?
Keep it short and to the point. 35.4. What is the ratio of the Value added (current US$) of 1961 in Upper middle income to that in Bangladesh?
Give a very brief answer. 28.27. What is the ratio of the Value added (current US$) in 1962 in Upper middle income to that in Bangladesh?
Keep it short and to the point. 28.97. What is the ratio of the Value added (current US$) of 1963 in Upper middle income to that in Bangladesh?
Offer a very short reply. 29.06. What is the ratio of the Value added (current US$) in 1960 in Upper middle income to that in Benin?
Give a very brief answer. 545.27. What is the ratio of the Value added (current US$) in 1961 in Upper middle income to that in Benin?
Ensure brevity in your answer.  462.69. What is the ratio of the Value added (current US$) in 1962 in Upper middle income to that in Benin?
Offer a very short reply. 479.2. What is the ratio of the Value added (current US$) in 1963 in Upper middle income to that in Benin?
Offer a very short reply. 476.07. What is the ratio of the Value added (current US$) in 1960 in Upper middle income to that in Botswana?
Keep it short and to the point. 4102.17. What is the ratio of the Value added (current US$) in 1961 in Upper middle income to that in Botswana?
Your response must be concise. 3175.77. What is the ratio of the Value added (current US$) in 1962 in Upper middle income to that in Botswana?
Make the answer very short. 2982.43. What is the ratio of the Value added (current US$) in 1963 in Upper middle income to that in Botswana?
Offer a terse response. 2813.98. What is the ratio of the Value added (current US$) of 1960 in Upper middle income to that in Brazil?
Make the answer very short. 9.76. What is the ratio of the Value added (current US$) in 1961 in Upper middle income to that in Brazil?
Ensure brevity in your answer.  9.26. What is the ratio of the Value added (current US$) of 1962 in Upper middle income to that in Brazil?
Your answer should be very brief. 5.86. What is the ratio of the Value added (current US$) of 1963 in Upper middle income to that in Brazil?
Your answer should be compact. 5.86. What is the ratio of the Value added (current US$) in 1960 in Bangladesh to that in Benin?
Offer a terse response. 15.41. What is the ratio of the Value added (current US$) of 1961 in Bangladesh to that in Benin?
Ensure brevity in your answer.  16.36. What is the ratio of the Value added (current US$) in 1962 in Bangladesh to that in Benin?
Ensure brevity in your answer.  16.54. What is the ratio of the Value added (current US$) in 1963 in Bangladesh to that in Benin?
Provide a short and direct response. 16.38. What is the ratio of the Value added (current US$) of 1960 in Bangladesh to that in Botswana?
Provide a succinct answer. 115.9. What is the ratio of the Value added (current US$) of 1961 in Bangladesh to that in Botswana?
Your answer should be very brief. 112.32. What is the ratio of the Value added (current US$) in 1962 in Bangladesh to that in Botswana?
Give a very brief answer. 102.95. What is the ratio of the Value added (current US$) of 1963 in Bangladesh to that in Botswana?
Make the answer very short. 96.85. What is the ratio of the Value added (current US$) in 1960 in Bangladesh to that in Brazil?
Keep it short and to the point. 0.28. What is the ratio of the Value added (current US$) in 1961 in Bangladesh to that in Brazil?
Give a very brief answer. 0.33. What is the ratio of the Value added (current US$) of 1962 in Bangladesh to that in Brazil?
Offer a very short reply. 0.2. What is the ratio of the Value added (current US$) of 1963 in Bangladesh to that in Brazil?
Keep it short and to the point. 0.2. What is the ratio of the Value added (current US$) of 1960 in Benin to that in Botswana?
Your answer should be very brief. 7.52. What is the ratio of the Value added (current US$) in 1961 in Benin to that in Botswana?
Offer a very short reply. 6.86. What is the ratio of the Value added (current US$) in 1962 in Benin to that in Botswana?
Give a very brief answer. 6.22. What is the ratio of the Value added (current US$) in 1963 in Benin to that in Botswana?
Offer a terse response. 5.91. What is the ratio of the Value added (current US$) in 1960 in Benin to that in Brazil?
Offer a terse response. 0.02. What is the ratio of the Value added (current US$) in 1961 in Benin to that in Brazil?
Ensure brevity in your answer.  0.02. What is the ratio of the Value added (current US$) in 1962 in Benin to that in Brazil?
Your answer should be compact. 0.01. What is the ratio of the Value added (current US$) in 1963 in Benin to that in Brazil?
Offer a very short reply. 0.01. What is the ratio of the Value added (current US$) in 1960 in Botswana to that in Brazil?
Offer a terse response. 0. What is the ratio of the Value added (current US$) of 1961 in Botswana to that in Brazil?
Give a very brief answer. 0. What is the ratio of the Value added (current US$) of 1962 in Botswana to that in Brazil?
Ensure brevity in your answer.  0. What is the ratio of the Value added (current US$) in 1963 in Botswana to that in Brazil?
Ensure brevity in your answer.  0. What is the difference between the highest and the second highest Value added (current US$) in 1960?
Your answer should be compact. 4.27e+1. What is the difference between the highest and the second highest Value added (current US$) in 1961?
Offer a very short reply. 3.62e+1. What is the difference between the highest and the second highest Value added (current US$) of 1962?
Give a very brief answer. 3.88e+1. What is the difference between the highest and the second highest Value added (current US$) in 1963?
Provide a short and direct response. 4.01e+1. What is the difference between the highest and the lowest Value added (current US$) in 1960?
Your answer should be very brief. 5.38e+1. What is the difference between the highest and the lowest Value added (current US$) of 1961?
Your answer should be compact. 4.80e+1. What is the difference between the highest and the lowest Value added (current US$) in 1962?
Your answer should be compact. 5.15e+1. What is the difference between the highest and the lowest Value added (current US$) of 1963?
Make the answer very short. 5.42e+1. 